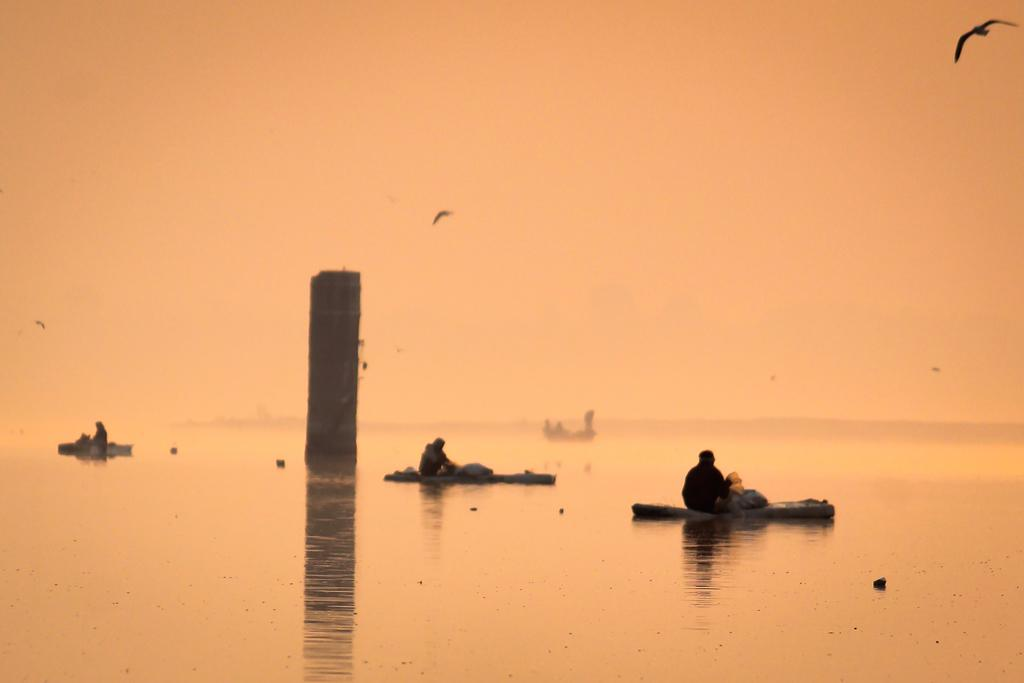What are the people in the image doing? The people in the image are sitting. What other living creatures can be seen in the image? There are birds visible in the image. How would you describe the overall color tone of the image? The image has an orange color tone. What type of prose is being read by the people in the image? There is no indication in the image that the people are reading any prose. 